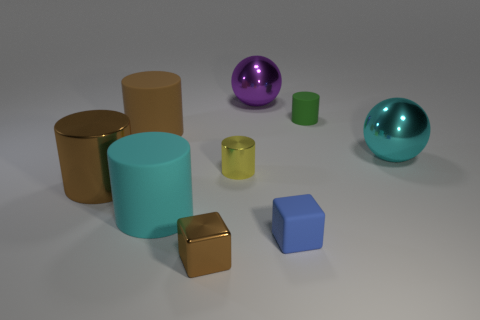Subtract all large cyan cylinders. How many cylinders are left? 4 Subtract all gray blocks. How many brown cylinders are left? 2 Subtract all yellow cylinders. How many cylinders are left? 4 Subtract 3 cylinders. How many cylinders are left? 2 Subtract all green cylinders. Subtract all cyan spheres. How many cylinders are left? 4 Subtract all big purple metallic spheres. Subtract all big purple blocks. How many objects are left? 8 Add 2 green rubber things. How many green rubber things are left? 3 Add 4 brown objects. How many brown objects exist? 7 Subtract 1 yellow cylinders. How many objects are left? 8 Subtract all spheres. How many objects are left? 7 